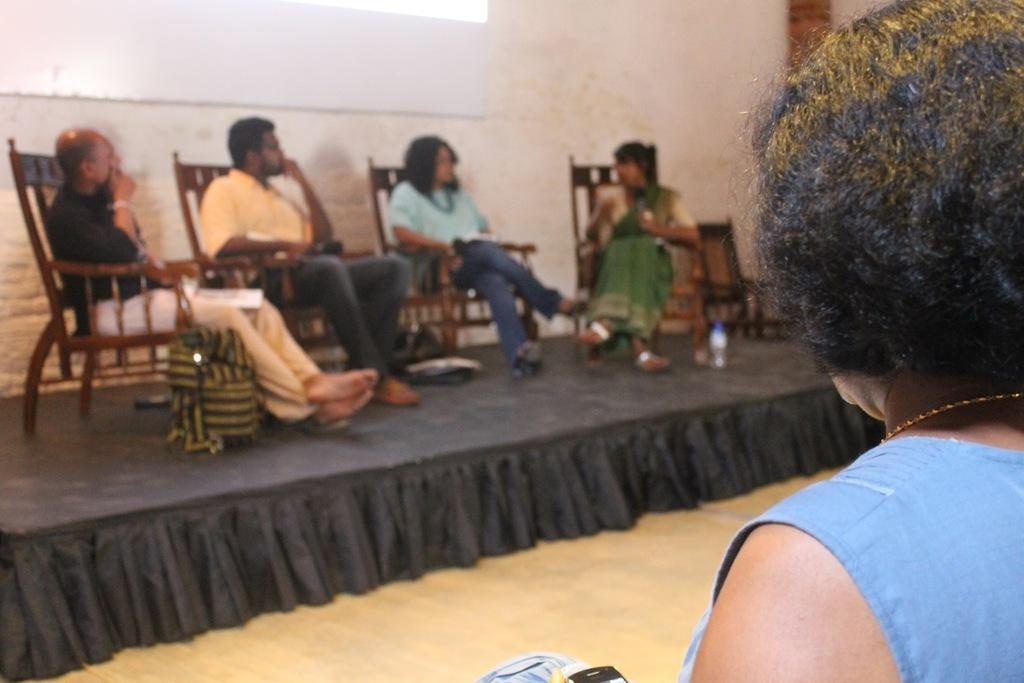How many people are present in the image? There are four people in the image. What are the people doing in the image? The four people are sitting on chairs. Can you describe the interaction between two of the people? One person is speaking with a woman. What are the other two people doing in the image? Two people are observing. Where is the woman located in the image? The woman is on the right side of the image. What type of ticket does the beetle have in the image? There is no beetle or ticket present in the image. 